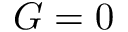<formula> <loc_0><loc_0><loc_500><loc_500>G = 0</formula> 